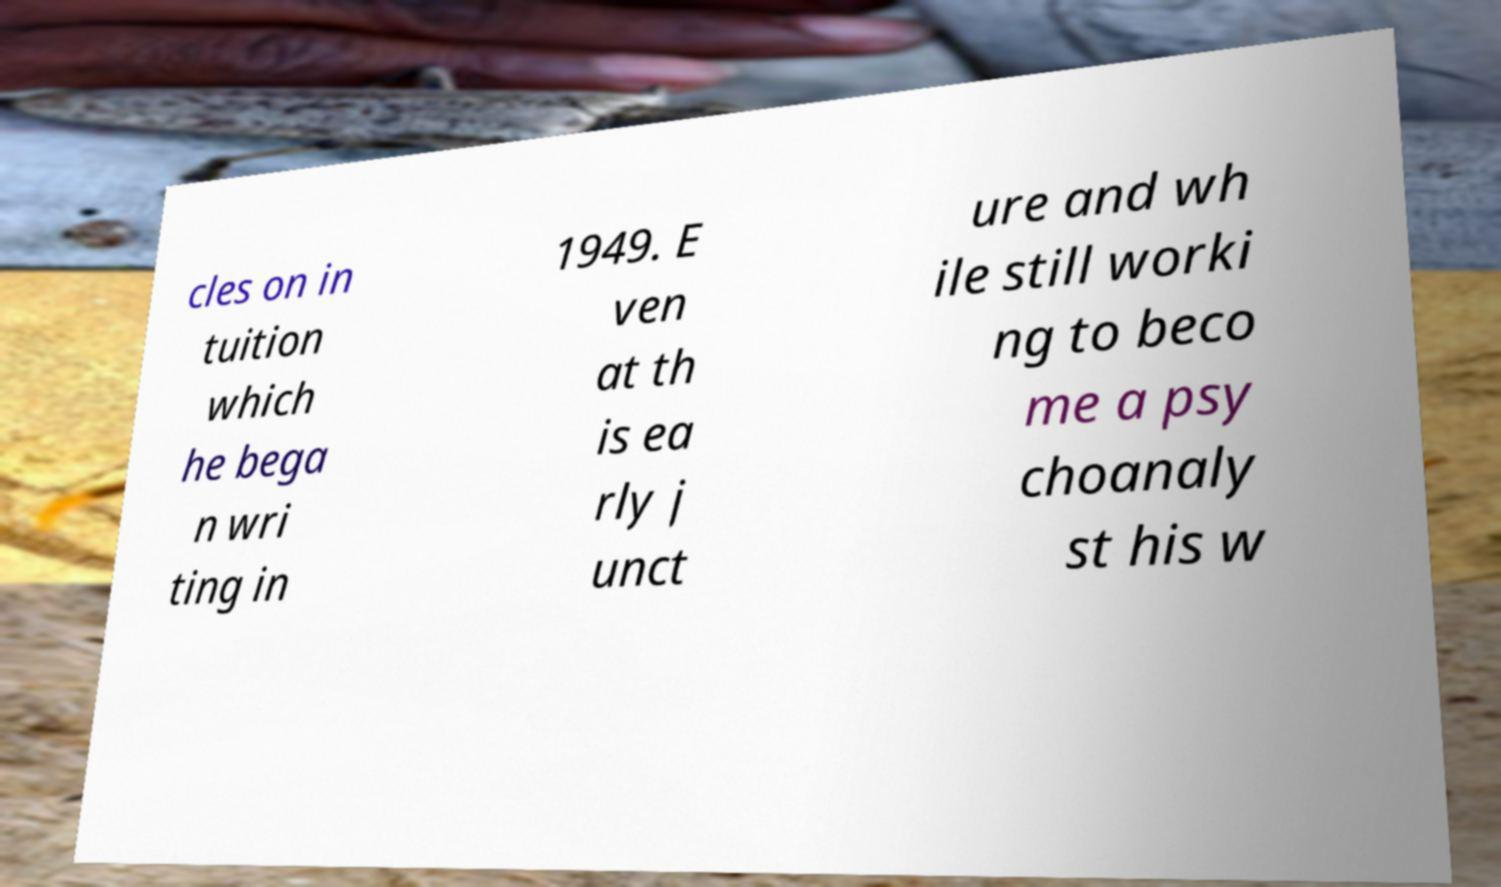Can you read and provide the text displayed in the image?This photo seems to have some interesting text. Can you extract and type it out for me? cles on in tuition which he bega n wri ting in 1949. E ven at th is ea rly j unct ure and wh ile still worki ng to beco me a psy choanaly st his w 